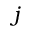Convert formula to latex. <formula><loc_0><loc_0><loc_500><loc_500>j</formula> 